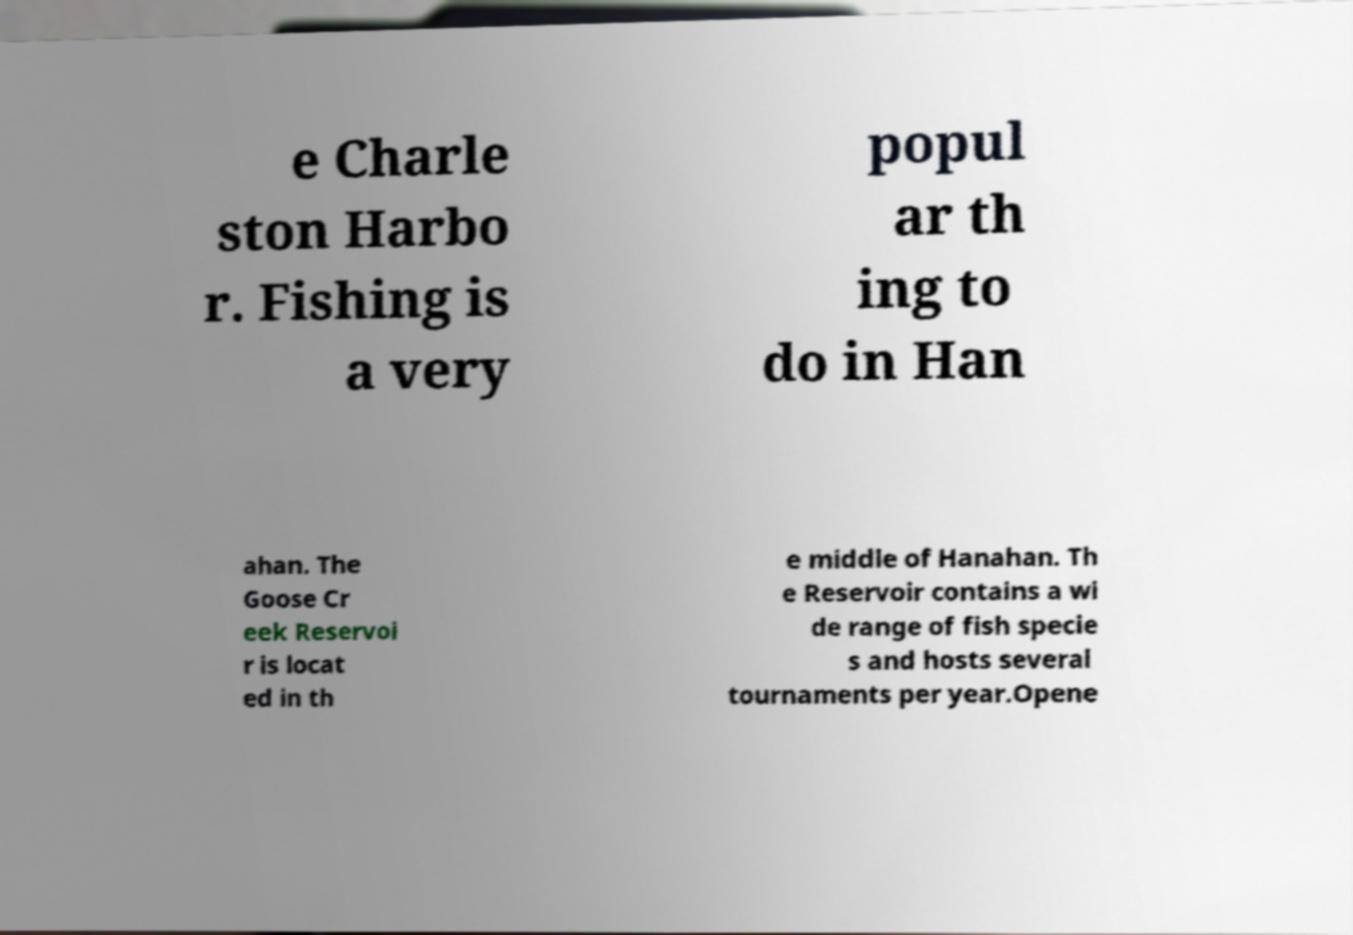Please read and relay the text visible in this image. What does it say? e Charle ston Harbo r. Fishing is a very popul ar th ing to do in Han ahan. The Goose Cr eek Reservoi r is locat ed in th e middle of Hanahan. Th e Reservoir contains a wi de range of fish specie s and hosts several tournaments per year.Opene 